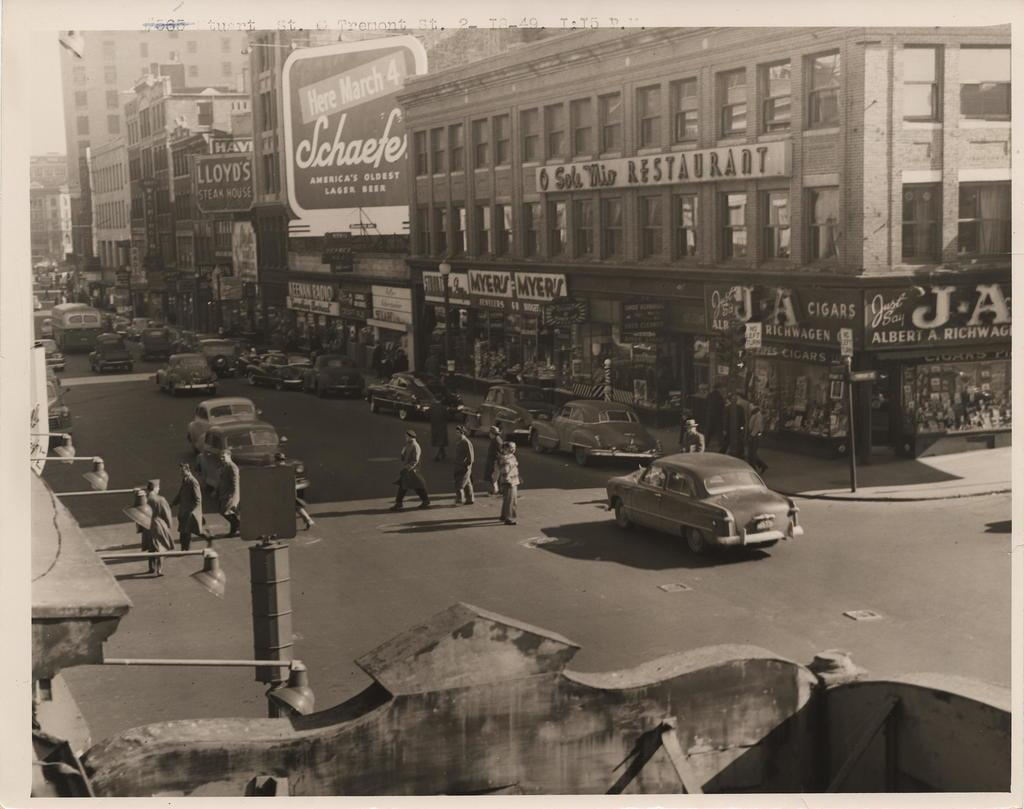What are the people in the image doing? There is a group of people walking on the road in the image. What else can be seen in the image besides the people? There are vehicles visible in the image. What can be seen in the background of the image? There are buildings in the background of the image. What type of notebook is the bear holding while walking on the road? There is no bear or notebook present in the image; it features a group of people walking on the road and vehicles. What color is the yarn that the bear is using to knit a scarf while walking on the road? There is no bear or yarn present in the image; it features a group of people walking on the road and vehicles. 